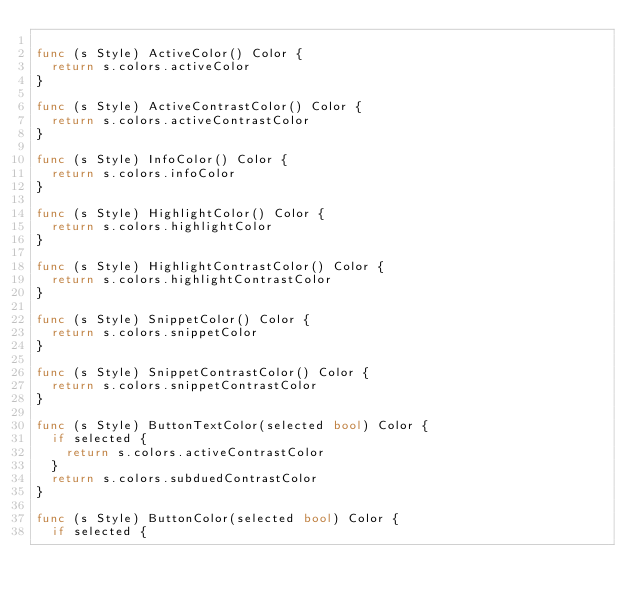<code> <loc_0><loc_0><loc_500><loc_500><_Go_>
func (s Style) ActiveColor() Color {
	return s.colors.activeColor
}

func (s Style) ActiveContrastColor() Color {
	return s.colors.activeContrastColor
}

func (s Style) InfoColor() Color {
	return s.colors.infoColor
}

func (s Style) HighlightColor() Color {
	return s.colors.highlightColor
}

func (s Style) HighlightContrastColor() Color {
	return s.colors.highlightContrastColor
}

func (s Style) SnippetColor() Color {
	return s.colors.snippetColor
}

func (s Style) SnippetContrastColor() Color {
	return s.colors.snippetContrastColor
}

func (s Style) ButtonTextColor(selected bool) Color {
	if selected {
		return s.colors.activeContrastColor
	}
	return s.colors.subduedContrastColor
}

func (s Style) ButtonColor(selected bool) Color {
	if selected {</code> 